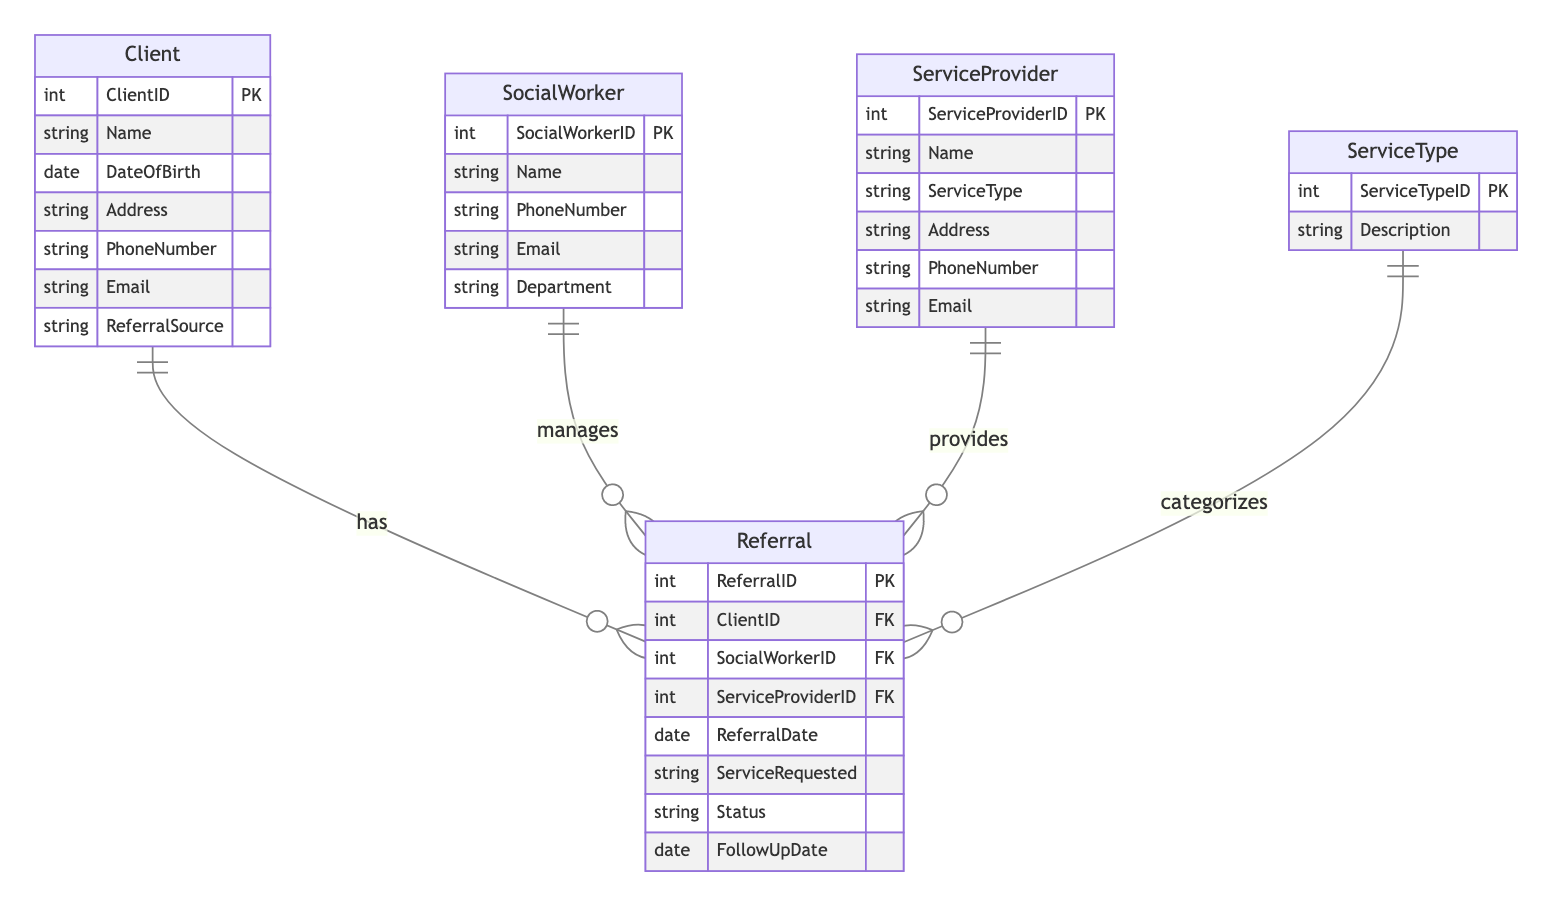What entity represents the client in this diagram? The diagram includes an entity named "Client" which is clearly labeled. This entity contains various attributes related to a client, confirming its identity as the client entity.
Answer: Client How many attributes does the SocialWorker entity have? By examining the "SocialWorker" entity in the diagram, it lists five attributes: SocialWorkerID, Name, PhoneNumber, Email, and Department. Thus, we count a total of five attributes.
Answer: 5 What is the relationship type between Client and Referral? The diagram indicates a "1-to-Many" relationship between the "Client" and "Referral" entities, meaning one client can have multiple referrals. Thus, the relationship type can be summarized in that format.
Answer: 1-to-Many How many entities are present in this diagram? The diagram shows a total of five distinct entities: Client, SocialWorker, ServiceProvider, Referral, and ServiceType. Counting these gives us the total entities present.
Answer: 5 What is the primary key of the Referral entity? In the diagram, the "Referral" entity lists "ReferralID" as its primary key (PK), identifying it uniquely within that entity.
Answer: ReferralID Which entity categorizes the referrals? The "ServiceType" entity is explicitly linked to the "Referral" entity in the diagram and is described as categorizing the referrals. Therefore, "ServiceType" is the entity that serves this purpose.
Answer: ServiceType What is the minimum number of referrals a client can have? The diagram indicates that a "Client" can have a "1-to-Many" relationship with "Referral," meaning it's possible for a client to have at least zero referrals, as they are not required to have any.
Answer: 0 What is the maximum number of referrals a single social worker can manage? The relationship between "SocialWorker" and "Referral" is a "1-to-Many" relationship, signifying that each social worker can manage many referrals, hence there is no specified maximum in the context of this diagram.
Answer: Many What entity does the ServiceProvider entity provide? The diagram clarifies that the "ServiceProvider" entity has a relationship with "Referral" where it provides the services associated with referrals. Therefore, it indicates the provision of referrals.
Answer: Referrals 